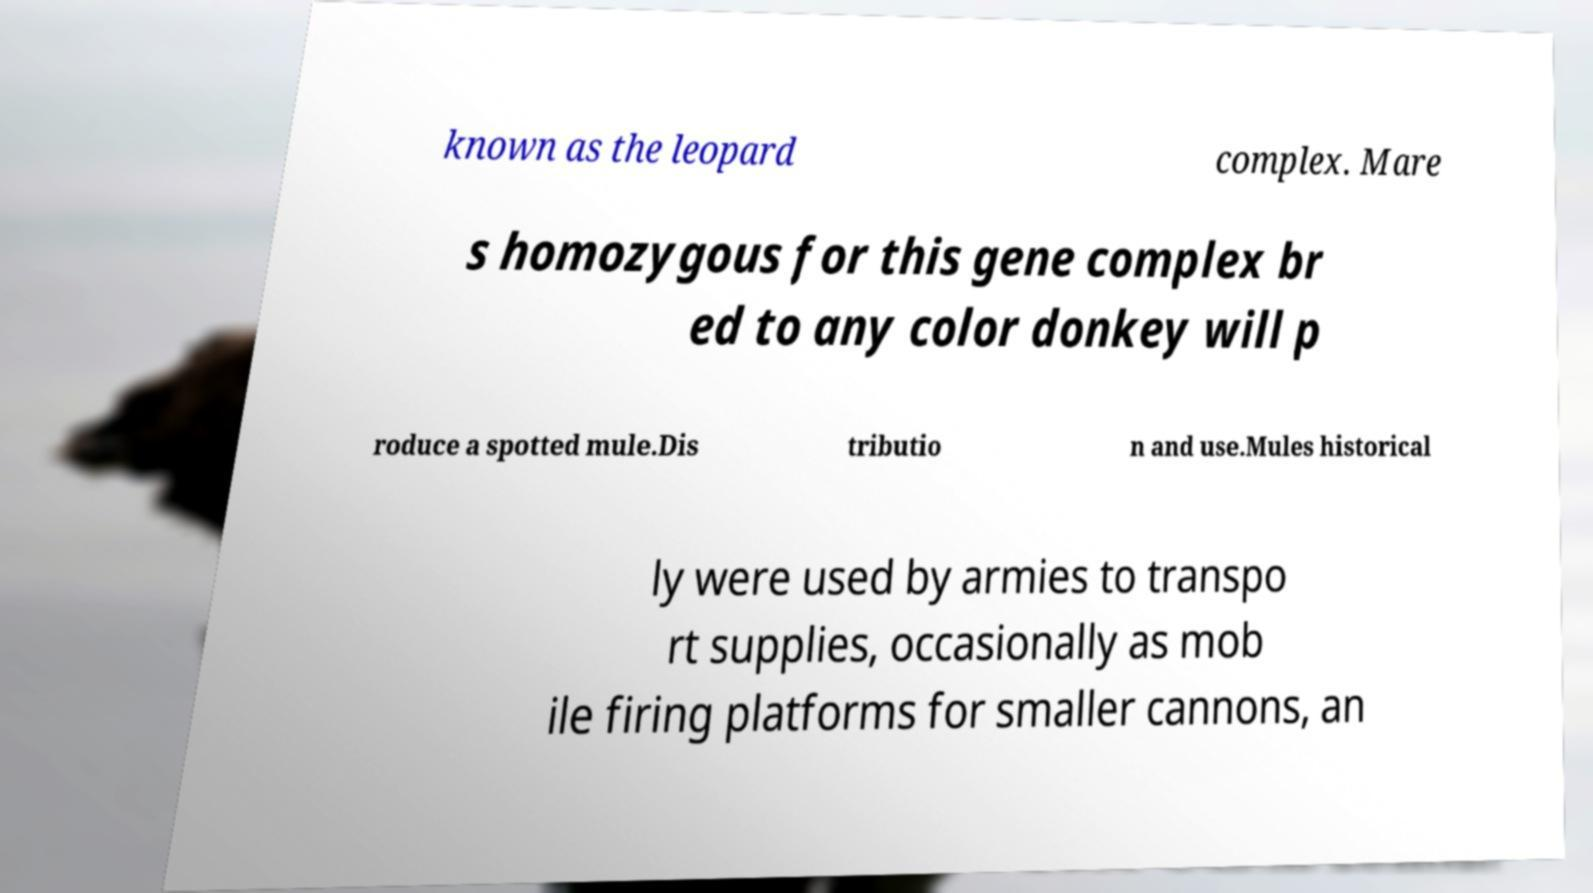Can you accurately transcribe the text from the provided image for me? known as the leopard complex. Mare s homozygous for this gene complex br ed to any color donkey will p roduce a spotted mule.Dis tributio n and use.Mules historical ly were used by armies to transpo rt supplies, occasionally as mob ile firing platforms for smaller cannons, an 